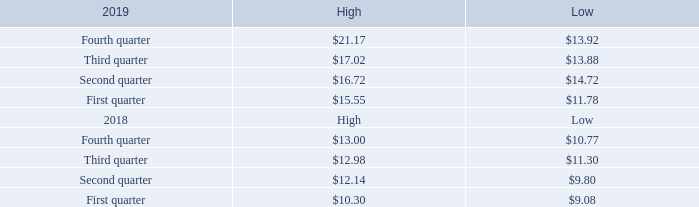Item 5. Market for Registrant's Common Equity, Related Shareholder Matters and Issuer Purchases of Equity Securities.
Our common shares, without par value, are traded on the NASDAQ Stock Market LLC under the symbol “AGYS”. The high and low sales prices for the common shares for each quarter during the past two fiscal years are presented in the table below.
The closing price of the common shares on May 21, 2019, was $22.51 per share. There were 1,561 active shareholders of record.
We did not pay dividends in fiscal 2019 or 2018 and are unlikely to do so in the foreseeable future. The current policy of the Board of Directors is to retain any available earnings for use in the operations of our business.
What was the closing price of shares on May 21, 2019? $22.51 per share. What were the number of active shareholders on May 21, 2019? 1,561. What was the High for fourth quarter 2019 per share? $21.17. What was the increase / (decrease) in the 2019 fourth quarter between low to high? 21.17 - 13.92
Answer: 7.25. What was the average 2019 third quarter for high and low? (17.02 + 13.88) / 2
Answer: 15.45. What was the increase / (decrease) in the 2019 second quarter between low and high? 16.72 - 14.72
Answer: 2. 